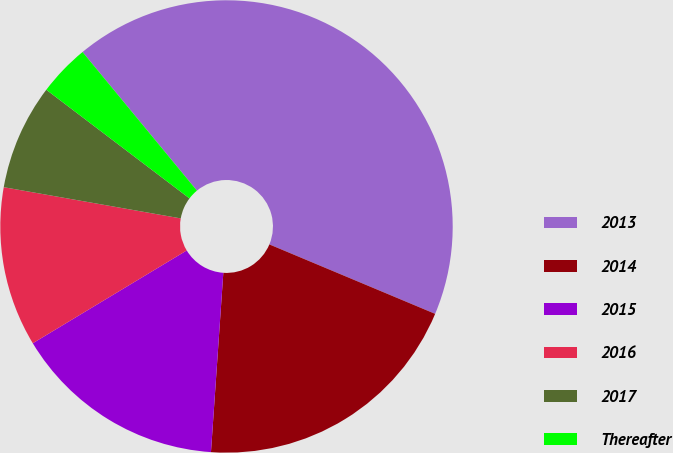<chart> <loc_0><loc_0><loc_500><loc_500><pie_chart><fcel>2013<fcel>2014<fcel>2015<fcel>2016<fcel>2017<fcel>Thereafter<nl><fcel>42.29%<fcel>19.78%<fcel>15.27%<fcel>11.41%<fcel>7.55%<fcel>3.69%<nl></chart> 